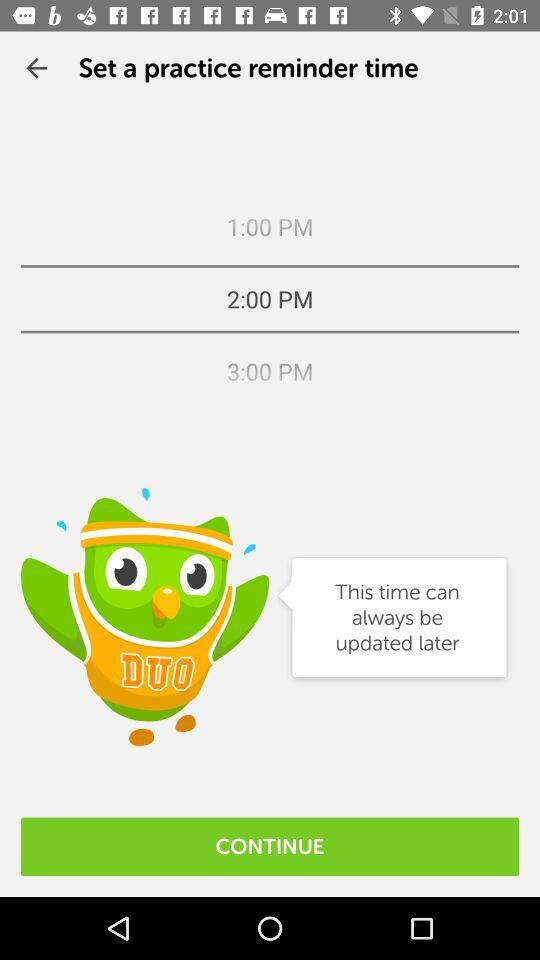Which is the selected time? The selected time is 2:00 PM. 